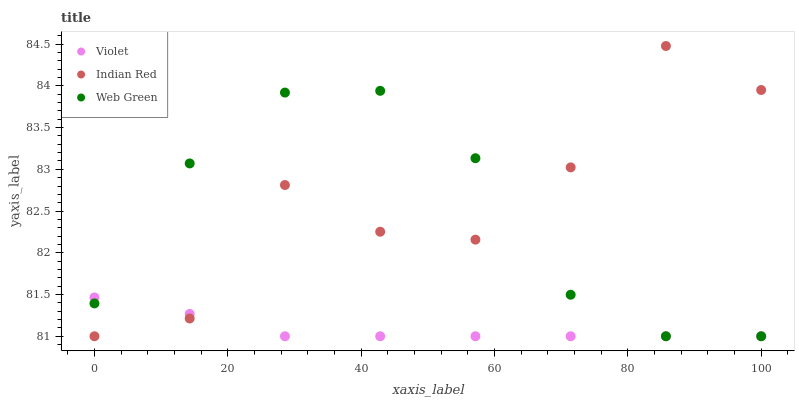Does Violet have the minimum area under the curve?
Answer yes or no. Yes. Does Indian Red have the maximum area under the curve?
Answer yes or no. Yes. Does Indian Red have the minimum area under the curve?
Answer yes or no. No. Does Violet have the maximum area under the curve?
Answer yes or no. No. Is Violet the smoothest?
Answer yes or no. Yes. Is Indian Red the roughest?
Answer yes or no. Yes. Is Indian Red the smoothest?
Answer yes or no. No. Is Violet the roughest?
Answer yes or no. No. Does Web Green have the lowest value?
Answer yes or no. Yes. Does Indian Red have the highest value?
Answer yes or no. Yes. Does Violet have the highest value?
Answer yes or no. No. Does Violet intersect Web Green?
Answer yes or no. Yes. Is Violet less than Web Green?
Answer yes or no. No. Is Violet greater than Web Green?
Answer yes or no. No. 